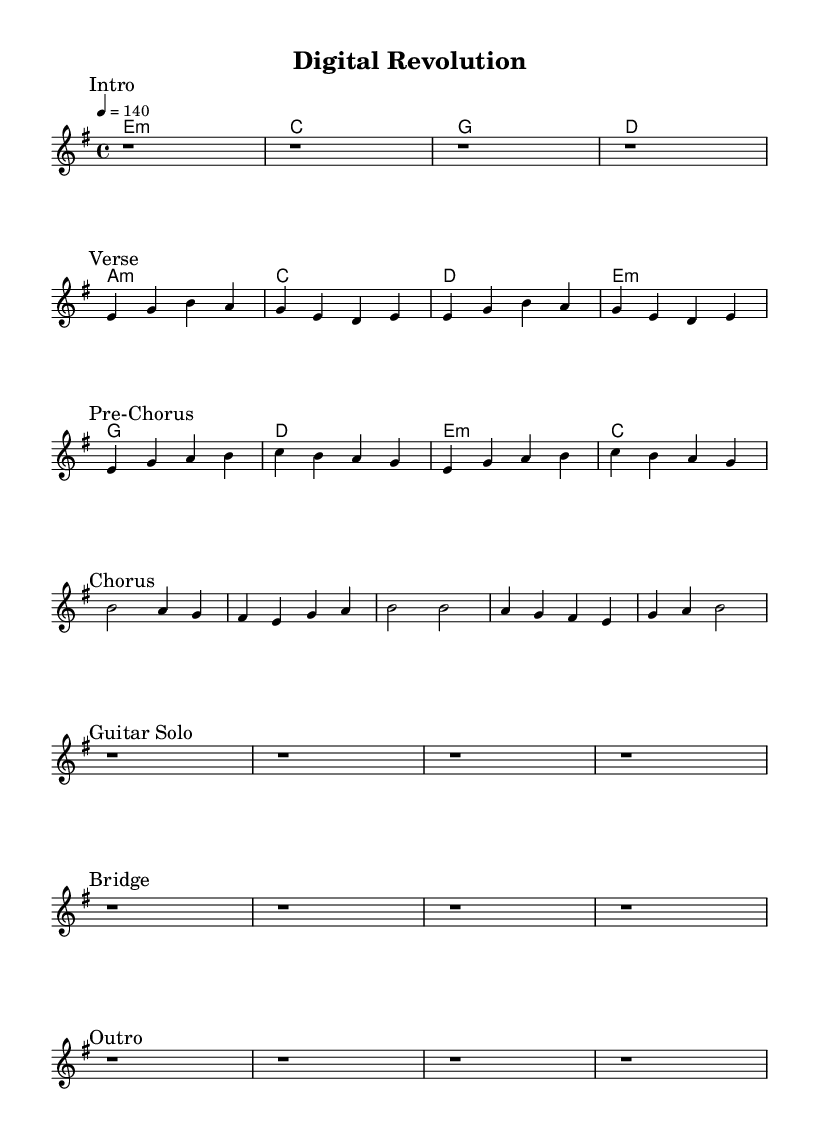What is the key signature of this music? The key signature is E minor, which has one sharp (F#). This can be found noted in the \key directive at the start of the global block in the code.
Answer: E minor What is the time signature of the piece? The time signature is 4/4, as indicated by the \time directive in the global settings. Each measure has four beats, which is typical for heavy metal music.
Answer: 4/4 What is the tempo marking for the piece? The tempo marking is quarter note equals 140, found in the \tempo directive. This indicates a fast pace, suitable for energetic heavy metal.
Answer: 140 How many measures are there in the "Verse" section? The "Verse" section includes two repetitions of the melody, each consisting of four measures, resulting in a total of eight measures.
Answer: 8 What chord follows the first measure of the "Chorus"? The chord that follows the first measure of the "Chorus" is B. This can be verified by looking at the harmony section aligning with the corresponding melody in the score.
Answer: B What is the structure of the song in terms of sections? The structure includes an Intro, Verse, Pre-Chorus, Chorus, Guitar Solo, Bridge, and Outro, as noted in the marks throughout the sheet music. This reflects a typical heavy metal song format.
Answer: Intro, Verse, Pre-Chorus, Chorus, Guitar Solo, Bridge, Outro 